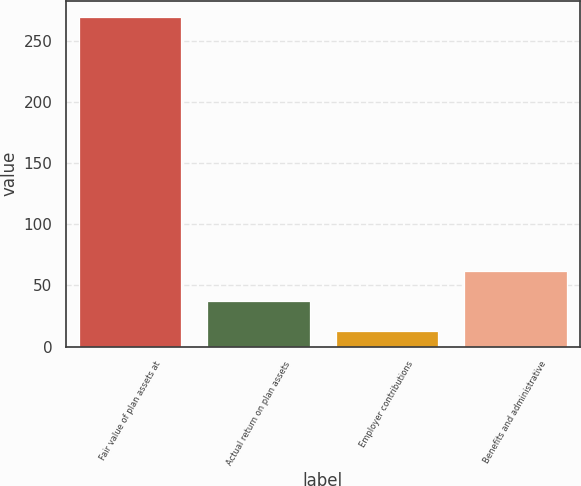Convert chart. <chart><loc_0><loc_0><loc_500><loc_500><bar_chart><fcel>Fair value of plan assets at<fcel>Actual return on plan assets<fcel>Employer contributions<fcel>Benefits and administrative<nl><fcel>268.89<fcel>37.29<fcel>12.9<fcel>61.68<nl></chart> 